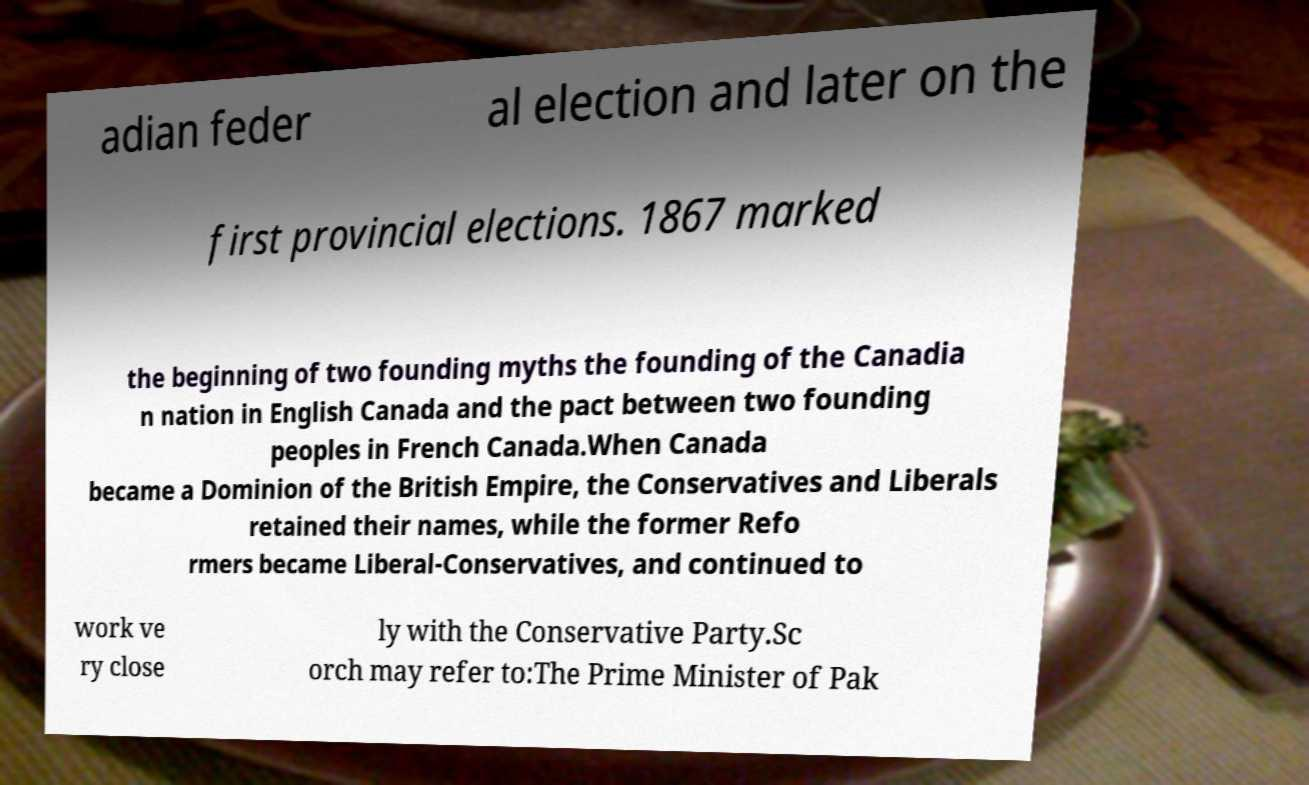I need the written content from this picture converted into text. Can you do that? adian feder al election and later on the first provincial elections. 1867 marked the beginning of two founding myths the founding of the Canadia n nation in English Canada and the pact between two founding peoples in French Canada.When Canada became a Dominion of the British Empire, the Conservatives and Liberals retained their names, while the former Refo rmers became Liberal-Conservatives, and continued to work ve ry close ly with the Conservative Party.Sc orch may refer to:The Prime Minister of Pak 